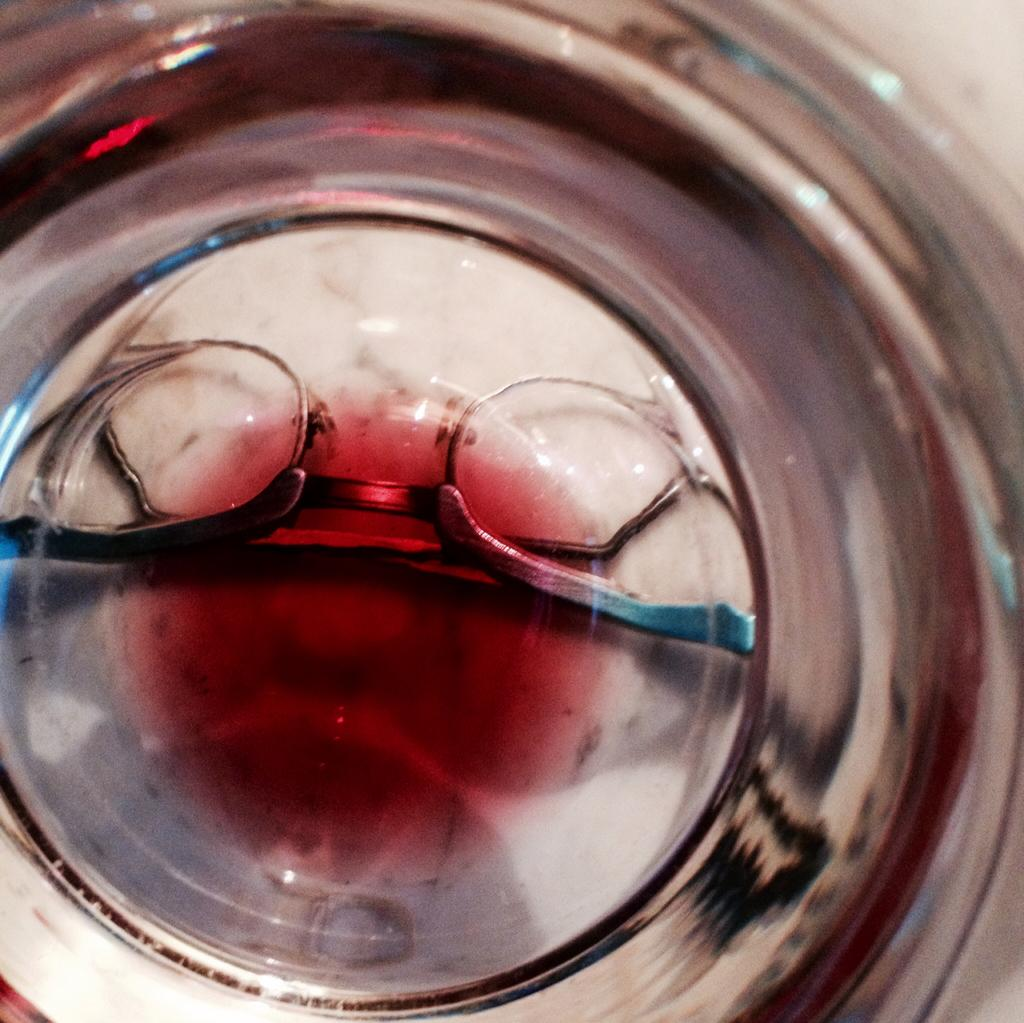What event is taking place in the image? There is a spectacle in the image, which suggests an event or performance is happening. What can be seen in the bowl in the image? There is a bowl with red liquid in the image. What type of help can be seen being provided in the image? There is no indication of help being provided in the image; it features a spectacle and a bowl with red liquid. What does the cellar look like in the image? There is no cellar present in the image. 